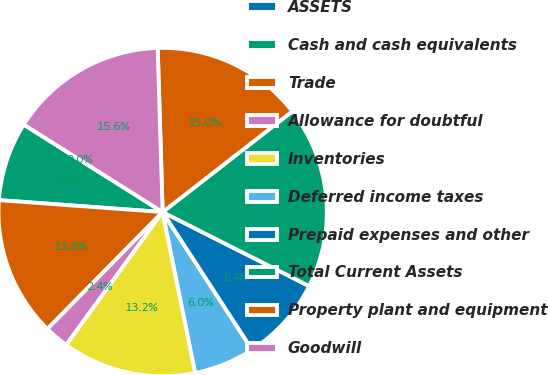Convert chart to OTSL. <chart><loc_0><loc_0><loc_500><loc_500><pie_chart><fcel>ASSETS<fcel>Cash and cash equivalents<fcel>Trade<fcel>Allowance for doubtful<fcel>Inventories<fcel>Deferred income taxes<fcel>Prepaid expenses and other<fcel>Total Current Assets<fcel>Property plant and equipment<fcel>Goodwill<nl><fcel>0.0%<fcel>7.79%<fcel>13.77%<fcel>2.4%<fcel>13.17%<fcel>5.99%<fcel>8.38%<fcel>17.96%<fcel>14.97%<fcel>15.57%<nl></chart> 